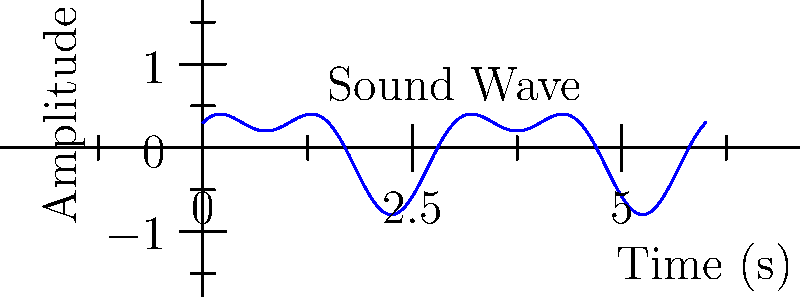As a conductor, you're analyzing a complex sound wave produced by your orchestra. The wave can be modeled by the function $$A(t) = 0.5\sin(\frac{2\pi t}{3}) + 0.3\cos(\frac{4\pi t}{3})$$ where $A$ is the amplitude and $t$ is time in seconds. What is the period of this combined wave? To find the period of this combined wave, we need to follow these steps:

1) First, recall that for a function of the form $\sin(2\pi ft)$ or $\cos(2\pi ft)$, the period is $\frac{1}{f}$.

2) In our function, we have two terms:
   $$0.5\sin(\frac{2\pi t}{3}) \text{ and } 0.3\cos(\frac{4\pi t}{3})$$

3) For the sine term:
   $\frac{2\pi t}{3} = 2\pi ft$, so $f = \frac{1}{3}$
   The period of this term is $\frac{1}{f} = 3$ seconds.

4) For the cosine term:
   $\frac{4\pi t}{3} = 2\pi ft$, so $f = \frac{2}{3}$
   The period of this term is $\frac{1}{f} = \frac{3}{2}$ seconds.

5) The period of the combined wave will be the least common multiple (LCM) of these two periods.

6) LCM(3, 3/2) = 3

Therefore, the period of the combined wave is 3 seconds.
Answer: 3 seconds 